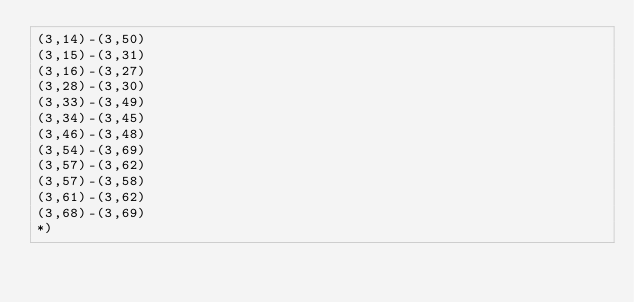Convert code to text. <code><loc_0><loc_0><loc_500><loc_500><_OCaml_>(3,14)-(3,50)
(3,15)-(3,31)
(3,16)-(3,27)
(3,28)-(3,30)
(3,33)-(3,49)
(3,34)-(3,45)
(3,46)-(3,48)
(3,54)-(3,69)
(3,57)-(3,62)
(3,57)-(3,58)
(3,61)-(3,62)
(3,68)-(3,69)
*)
</code> 